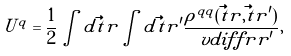<formula> <loc_0><loc_0><loc_500><loc_500>U ^ { q } = \frac { 1 } { 2 } \int d \vec { t } { r } \int d \vec { t } { r ^ { \prime } } \frac { \rho ^ { q q } ( \vec { t } { r } , \vec { t } { r ^ { \prime } } ) } { \ v d i f f { r } { r ^ { \prime } } } ,</formula> 